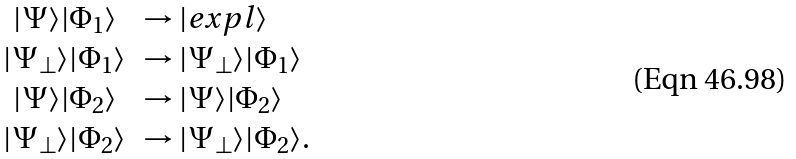Convert formula to latex. <formula><loc_0><loc_0><loc_500><loc_500>\begin{array} { c l c r } | \Psi \rangle | \Phi _ { 1 } \rangle & \rightarrow | e x p l \rangle \\ | \Psi _ { \perp } \rangle | \Phi _ { 1 } \rangle & \rightarrow | \Psi _ { \perp } \rangle | \Phi _ { 1 } \rangle \\ | \Psi \rangle | \Phi _ { 2 } \rangle & \rightarrow | \Psi \rangle | \Phi _ { 2 } \rangle \\ | \Psi _ { \perp } \rangle | \Phi _ { 2 } \rangle & \rightarrow | \Psi _ { \perp } \rangle | \Phi _ { 2 } \rangle . \end{array}</formula> 